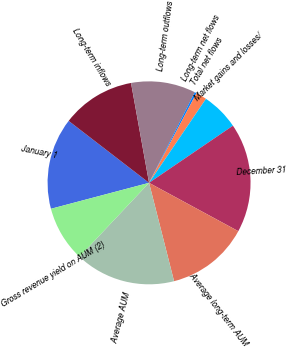Convert chart. <chart><loc_0><loc_0><loc_500><loc_500><pie_chart><fcel>January 1<fcel>Long-term inflows<fcel>Long-term outflows<fcel>Long-term net flows<fcel>Total net flows<fcel>Market gains and losses/<fcel>December 31<fcel>Average long-term AUM<fcel>Average AUM<fcel>Gross revenue yield on AUM (2)<nl><fcel>14.57%<fcel>11.71%<fcel>10.29%<fcel>0.3%<fcel>1.73%<fcel>6.01%<fcel>17.42%<fcel>13.14%<fcel>15.99%<fcel>8.86%<nl></chart> 